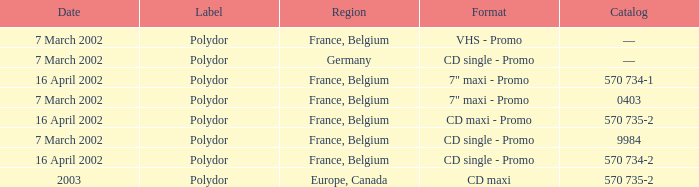Which region had a release format of CD Maxi? Europe, Canada. 